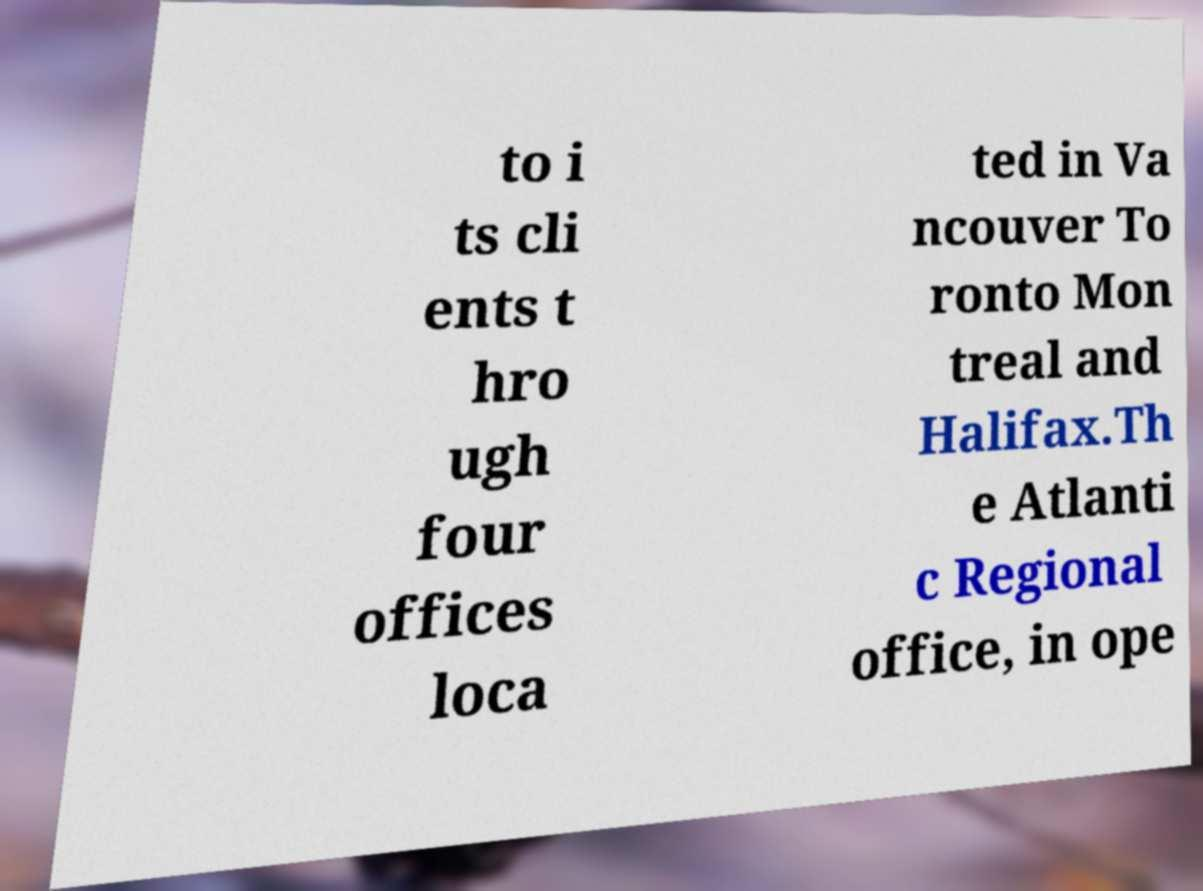What messages or text are displayed in this image? I need them in a readable, typed format. to i ts cli ents t hro ugh four offices loca ted in Va ncouver To ronto Mon treal and Halifax.Th e Atlanti c Regional office, in ope 